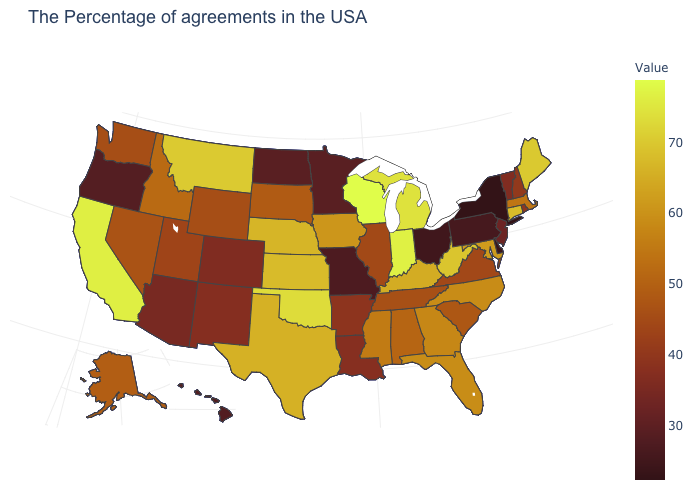Among the states that border New Mexico , which have the highest value?
Answer briefly. Oklahoma. Among the states that border Massachusetts , does Vermont have the lowest value?
Write a very short answer. No. Among the states that border New Mexico , does Arizona have the lowest value?
Quick response, please. Yes. Does Wisconsin have the highest value in the MidWest?
Short answer required. Yes. Among the states that border North Dakota , which have the highest value?
Give a very brief answer. Montana. Which states have the lowest value in the USA?
Give a very brief answer. New York. 